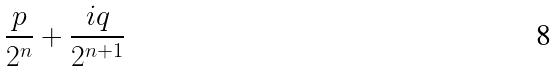Convert formula to latex. <formula><loc_0><loc_0><loc_500><loc_500>\frac { p } { 2 ^ { n } } + \frac { i q } { 2 ^ { n + 1 } }</formula> 